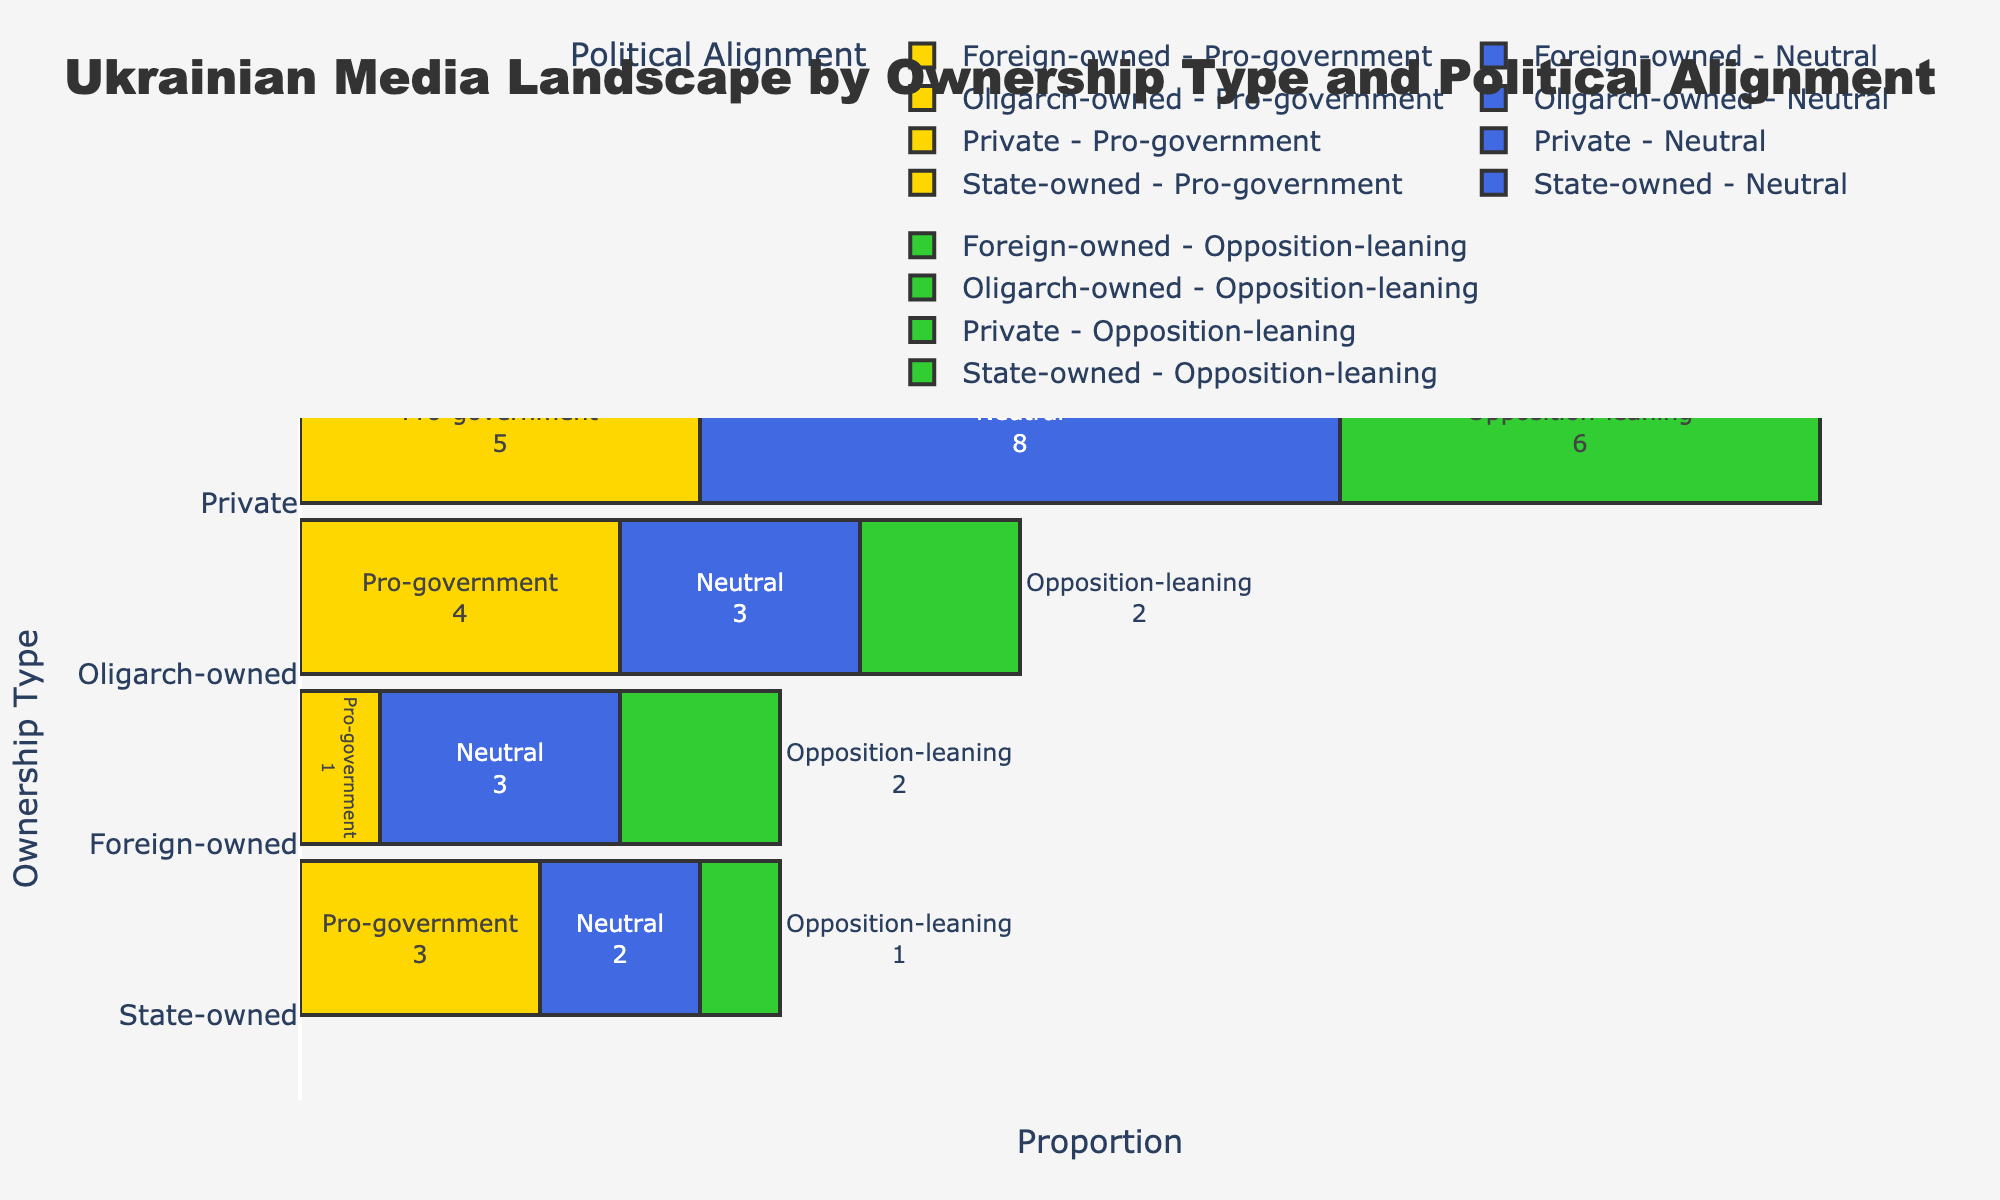What is the title of the plot? The title is located at the top of the figure and usually provides a clear indication of what the plot is about. In this case, the title is "Ukrainian Media Landscape by Ownership Type and Political Alignment".
Answer: Ukrainian Media Landscape by Ownership Type and Political Alignment Which ownership type has the largest total proportion of media? By summing the sizes of media for each ownership type, we can determine which has the largest total proportion. The "Private" ownership type has the largest combined size.
Answer: Private How many media outlets are both State-owned and Pro-government? By examining the segment corresponding to State-owned and Pro-government in the figure, it is indicated that there are 3 such media outlets.
Answer: 3 Which political alignment is the least represented in Foreign-owned media? From the Foreign-owned category, comparing the sizes of the segments, the "Pro-government" alignment has the smallest representation.
Answer: Pro-government What is the combined count of Neutral and Opposition-leaning media in Oligarch-owned category? Adding the counts for Neutral (3) and Opposition-leaning (2) under Oligarch-owned, we get a total of 3 + 2 = 5.
Answer: 5 Compare the number of Neutral media outlets in Private vs Foreign-owned categories. Which has more? The figure shows that Private has 8 Neutral media outlets, while Foreign-owned has 3. Private has a greater number.
Answer: Private What proportion of the total media landscape does State-owned and Neutral make up? First, find the count for State-owned and Neutral (2). Then, calculate its proportion of the overall total (the sum of all counts): 2 / 40 (total count) = 0.05 or 5%.
Answer: 5% Which political alignment is most common across all ownership types? By visually examining the sizes of segments across all categories, the "Neutral" political alignment appears to be the most common.
Answer: Neutral What is the difference in the number of Pro-government media between Oligarch-owned and State-owned types? Oligarch-owned has 4 Pro-government media, and State-owned has 3. The difference is 4 - 3 = 1.
Answer: 1 How many total media outlets are Opposition-leaning across all ownership types? Summing Opposition-leaning media: State-owned (1) + Private (6) + Oligarch-owned (2) + Foreign-owned (2) = 1 + 6 + 2 + 2 = 11.
Answer: 11 